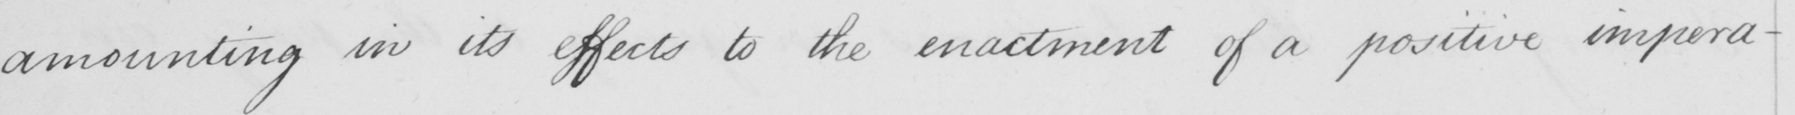Can you read and transcribe this handwriting? amounting in its effects to the enactment of a positive impera- 